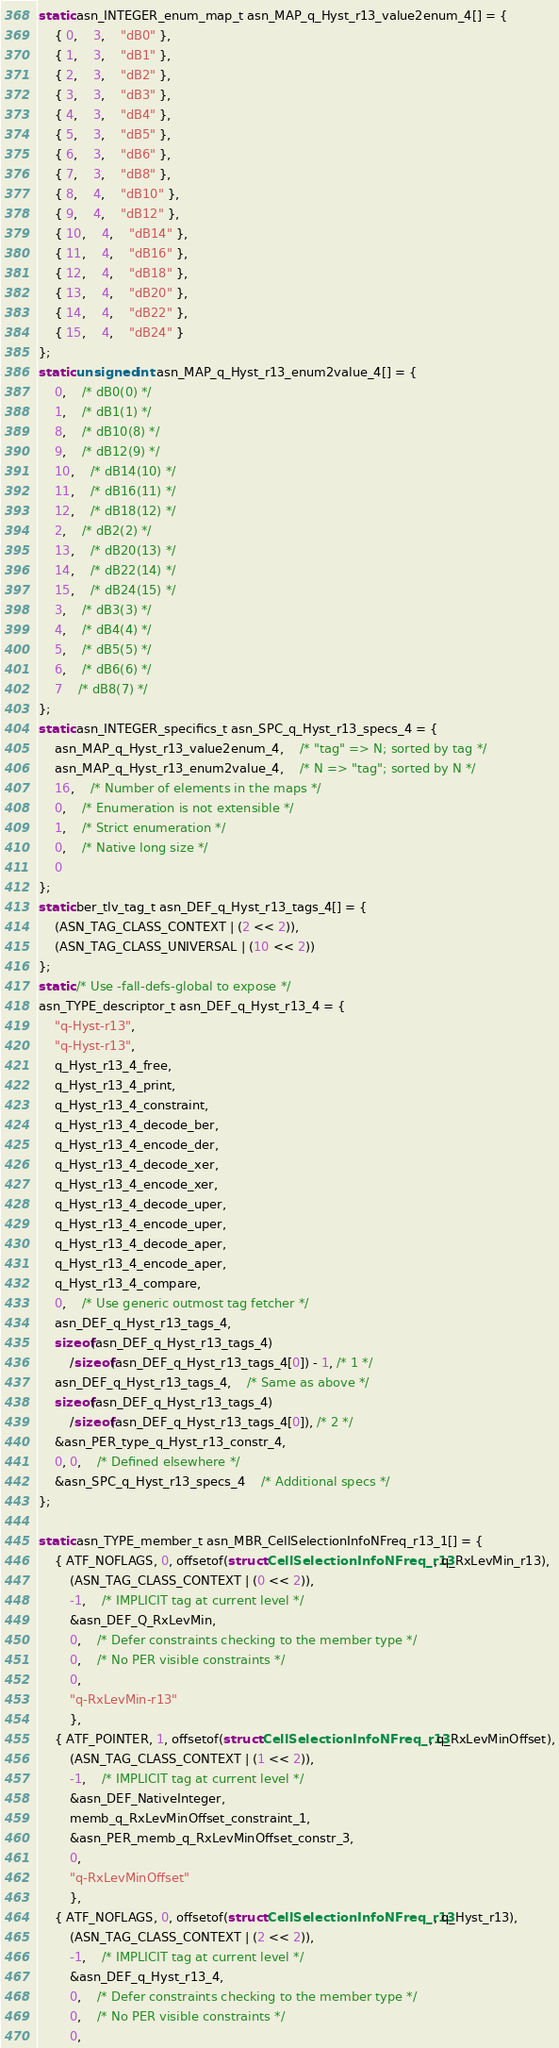<code> <loc_0><loc_0><loc_500><loc_500><_C_>static asn_INTEGER_enum_map_t asn_MAP_q_Hyst_r13_value2enum_4[] = {
	{ 0,	3,	"dB0" },
	{ 1,	3,	"dB1" },
	{ 2,	3,	"dB2" },
	{ 3,	3,	"dB3" },
	{ 4,	3,	"dB4" },
	{ 5,	3,	"dB5" },
	{ 6,	3,	"dB6" },
	{ 7,	3,	"dB8" },
	{ 8,	4,	"dB10" },
	{ 9,	4,	"dB12" },
	{ 10,	4,	"dB14" },
	{ 11,	4,	"dB16" },
	{ 12,	4,	"dB18" },
	{ 13,	4,	"dB20" },
	{ 14,	4,	"dB22" },
	{ 15,	4,	"dB24" }
};
static unsigned int asn_MAP_q_Hyst_r13_enum2value_4[] = {
	0,	/* dB0(0) */
	1,	/* dB1(1) */
	8,	/* dB10(8) */
	9,	/* dB12(9) */
	10,	/* dB14(10) */
	11,	/* dB16(11) */
	12,	/* dB18(12) */
	2,	/* dB2(2) */
	13,	/* dB20(13) */
	14,	/* dB22(14) */
	15,	/* dB24(15) */
	3,	/* dB3(3) */
	4,	/* dB4(4) */
	5,	/* dB5(5) */
	6,	/* dB6(6) */
	7	/* dB8(7) */
};
static asn_INTEGER_specifics_t asn_SPC_q_Hyst_r13_specs_4 = {
	asn_MAP_q_Hyst_r13_value2enum_4,	/* "tag" => N; sorted by tag */
	asn_MAP_q_Hyst_r13_enum2value_4,	/* N => "tag"; sorted by N */
	16,	/* Number of elements in the maps */
	0,	/* Enumeration is not extensible */
	1,	/* Strict enumeration */
	0,	/* Native long size */
	0
};
static ber_tlv_tag_t asn_DEF_q_Hyst_r13_tags_4[] = {
	(ASN_TAG_CLASS_CONTEXT | (2 << 2)),
	(ASN_TAG_CLASS_UNIVERSAL | (10 << 2))
};
static /* Use -fall-defs-global to expose */
asn_TYPE_descriptor_t asn_DEF_q_Hyst_r13_4 = {
	"q-Hyst-r13",
	"q-Hyst-r13",
	q_Hyst_r13_4_free,
	q_Hyst_r13_4_print,
	q_Hyst_r13_4_constraint,
	q_Hyst_r13_4_decode_ber,
	q_Hyst_r13_4_encode_der,
	q_Hyst_r13_4_decode_xer,
	q_Hyst_r13_4_encode_xer,
	q_Hyst_r13_4_decode_uper,
	q_Hyst_r13_4_encode_uper,
	q_Hyst_r13_4_decode_aper,
	q_Hyst_r13_4_encode_aper,
	q_Hyst_r13_4_compare,
	0,	/* Use generic outmost tag fetcher */
	asn_DEF_q_Hyst_r13_tags_4,
	sizeof(asn_DEF_q_Hyst_r13_tags_4)
		/sizeof(asn_DEF_q_Hyst_r13_tags_4[0]) - 1, /* 1 */
	asn_DEF_q_Hyst_r13_tags_4,	/* Same as above */
	sizeof(asn_DEF_q_Hyst_r13_tags_4)
		/sizeof(asn_DEF_q_Hyst_r13_tags_4[0]), /* 2 */
	&asn_PER_type_q_Hyst_r13_constr_4,
	0, 0,	/* Defined elsewhere */
	&asn_SPC_q_Hyst_r13_specs_4	/* Additional specs */
};

static asn_TYPE_member_t asn_MBR_CellSelectionInfoNFreq_r13_1[] = {
	{ ATF_NOFLAGS, 0, offsetof(struct CellSelectionInfoNFreq_r13, q_RxLevMin_r13),
		(ASN_TAG_CLASS_CONTEXT | (0 << 2)),
		-1,	/* IMPLICIT tag at current level */
		&asn_DEF_Q_RxLevMin,
		0,	/* Defer constraints checking to the member type */
		0,	/* No PER visible constraints */
		0,
		"q-RxLevMin-r13"
		},
	{ ATF_POINTER, 1, offsetof(struct CellSelectionInfoNFreq_r13, q_RxLevMinOffset),
		(ASN_TAG_CLASS_CONTEXT | (1 << 2)),
		-1,	/* IMPLICIT tag at current level */
		&asn_DEF_NativeInteger,
		memb_q_RxLevMinOffset_constraint_1,
		&asn_PER_memb_q_RxLevMinOffset_constr_3,
		0,
		"q-RxLevMinOffset"
		},
	{ ATF_NOFLAGS, 0, offsetof(struct CellSelectionInfoNFreq_r13, q_Hyst_r13),
		(ASN_TAG_CLASS_CONTEXT | (2 << 2)),
		-1,	/* IMPLICIT tag at current level */
		&asn_DEF_q_Hyst_r13_4,
		0,	/* Defer constraints checking to the member type */
		0,	/* No PER visible constraints */
		0,</code> 